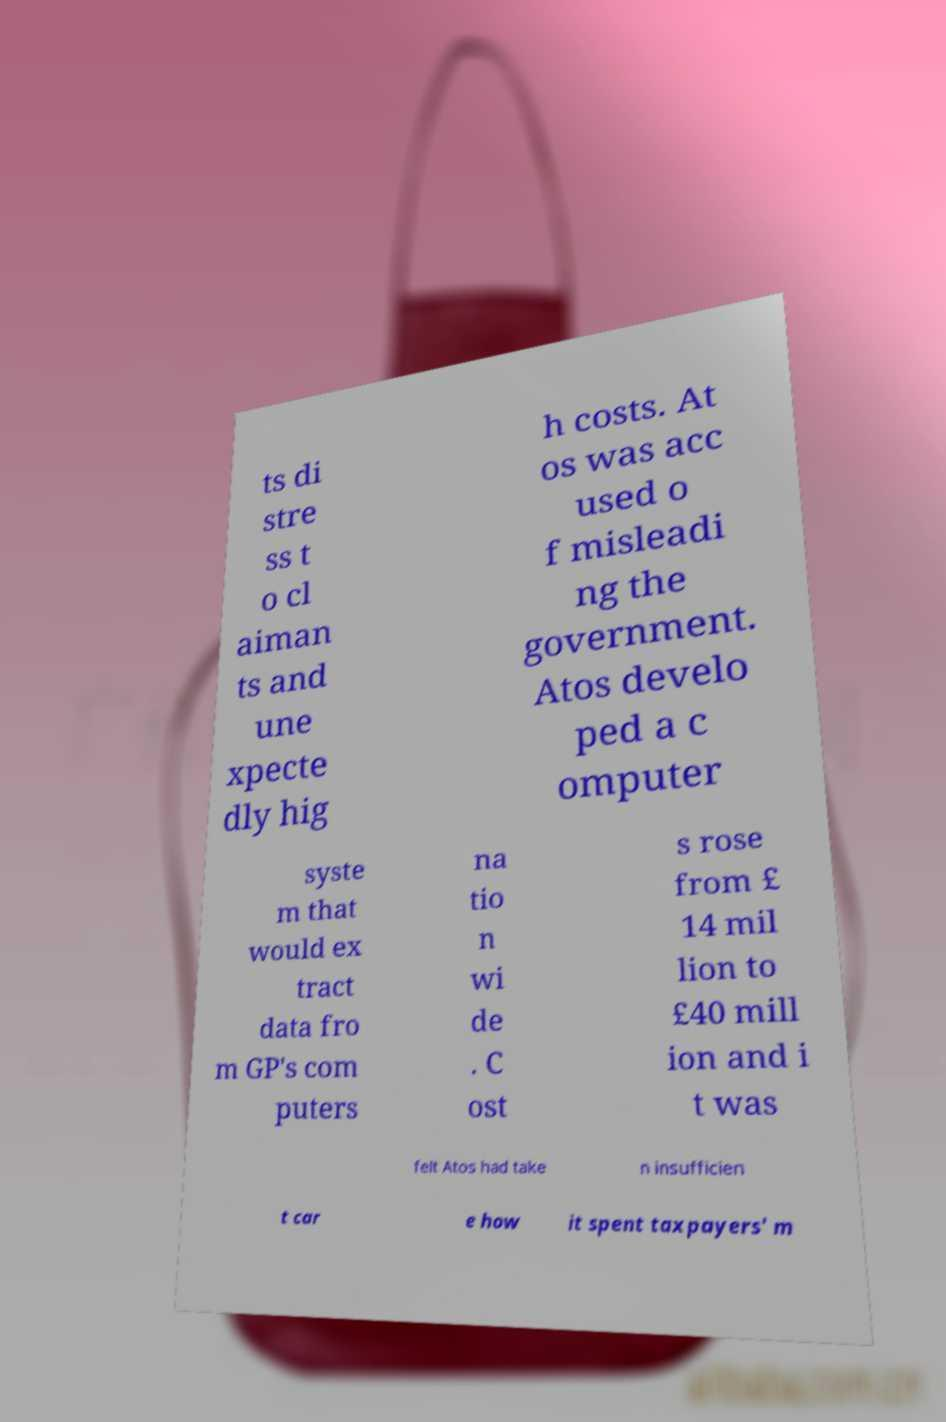Please read and relay the text visible in this image. What does it say? ts di stre ss t o cl aiman ts and une xpecte dly hig h costs. At os was acc used o f misleadi ng the government. Atos develo ped a c omputer syste m that would ex tract data fro m GP's com puters na tio n wi de . C ost s rose from £ 14 mil lion to £40 mill ion and i t was felt Atos had take n insufficien t car e how it spent taxpayers' m 